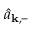<formula> <loc_0><loc_0><loc_500><loc_500>\hat { a } _ { k , - }</formula> 